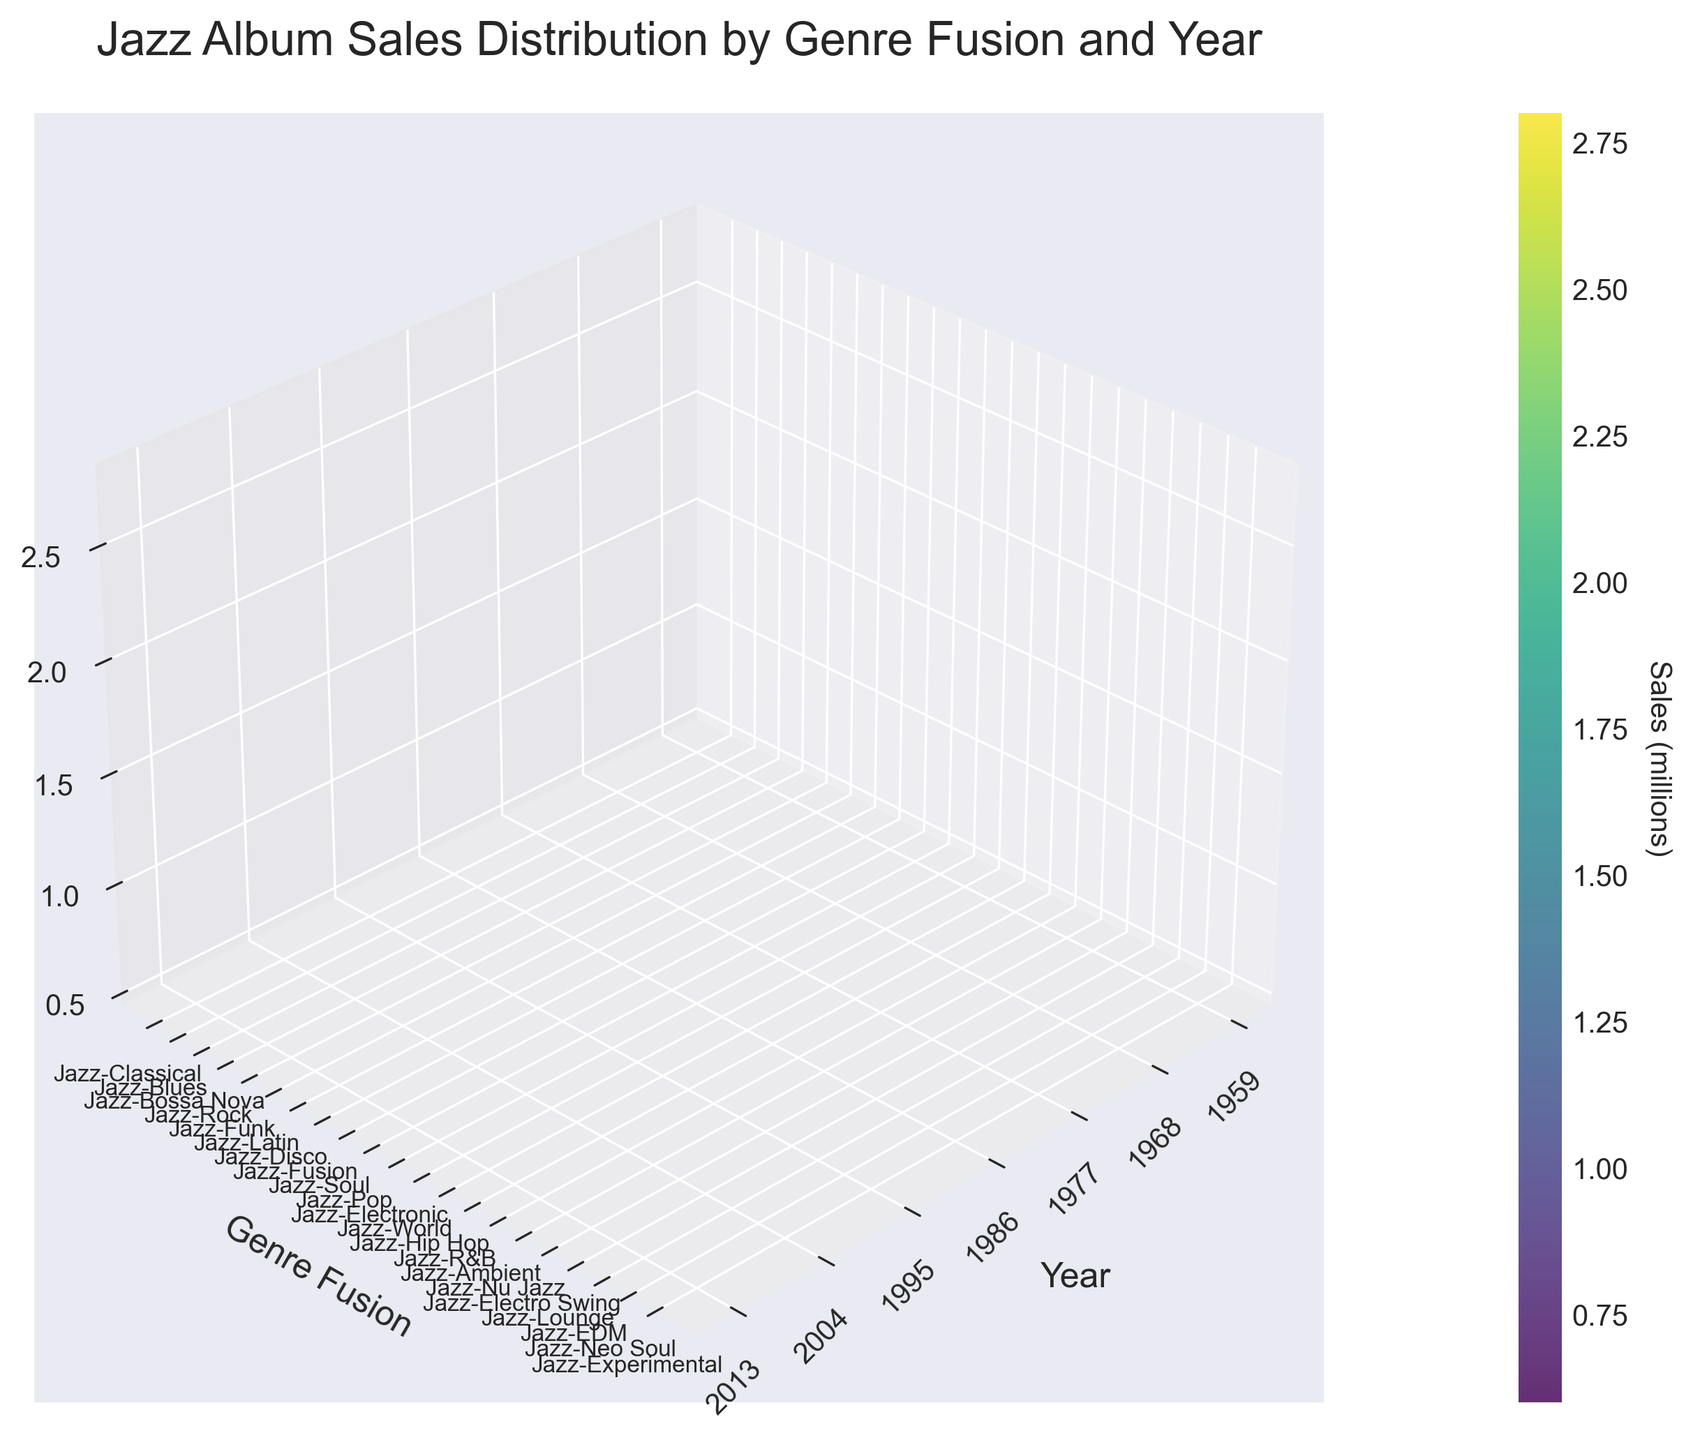What is the title of the figure? The title of the figure can be read at the top of the plot.
Answer: Jazz Album Sales Distribution by Genre Fusion and Year What does the colorbar represent? The colorbar on the side of the plot indicates the sales in millions of albums.
Answer: Sales in millions Which genre fusion had the highest sales in 1977? By looking at the surface plot at the x-coordinate for the year 1977 and observing the height (z-value), Jazz-Fusion appears to have the highest peak in that year.
Answer: Jazz-Fusion How many genre fusions are depicted in the plot? The y-axis labels list all the genre fusions. Counting these, there are 18 genre fusions represented.
Answer: 18 Which year has the overall highest sales across all genres? To find this, compare the peaks across different years. The year 1986 has the highest peaks overall, specifically for Jazz-Pop.
Answer: 1986 What is the sales difference between Jazz-Rock in 1968 and Jazz-EDM in 2013? Find the height (z-value) for Jazz-Rock in 1968 and subtract the height for Jazz-EDM in 2013. Jazz-Rock has 2.1 million and Jazz-EDM has 1.5 million, so the difference is 2.1 - 1.5 = 0.6 million.
Answer: 0.6 million Which genre fusion in 1959 had the lowest sales and what was it? Look at the sales levels (z-values) for all genres in 1959. Jazz-Bossa Nova has the lowest peak at 0.5 million.
Answer: Jazz-Bossa Nova, 0.5 million What is the average sales of all genre fusions in 1995? Find the sales (z-values) for all the genre fusions in 1995: Jazz-Hip Hop (2.2), Jazz-R&B (1.8), and Jazz-Ambient (0.6). Sum these (2.2 + 1.8 + 0.6 = 4.6) and divide by the number of genres (3) to get the average, which is 4.6 / 3 ≈ 1.53 million.
Answer: 1.53 million Does Jazz-Soul have higher sales in 1977 or does Jazz-Electronic have higher sales in 1986? Compare the z-values for Jazz-Soul in 1977 (1.6 million) and Jazz-Electronic in 1986 (1.3 million). Jazz-Soul in 1977 has higher sales.
Answer: Jazz-Soul in 1977 